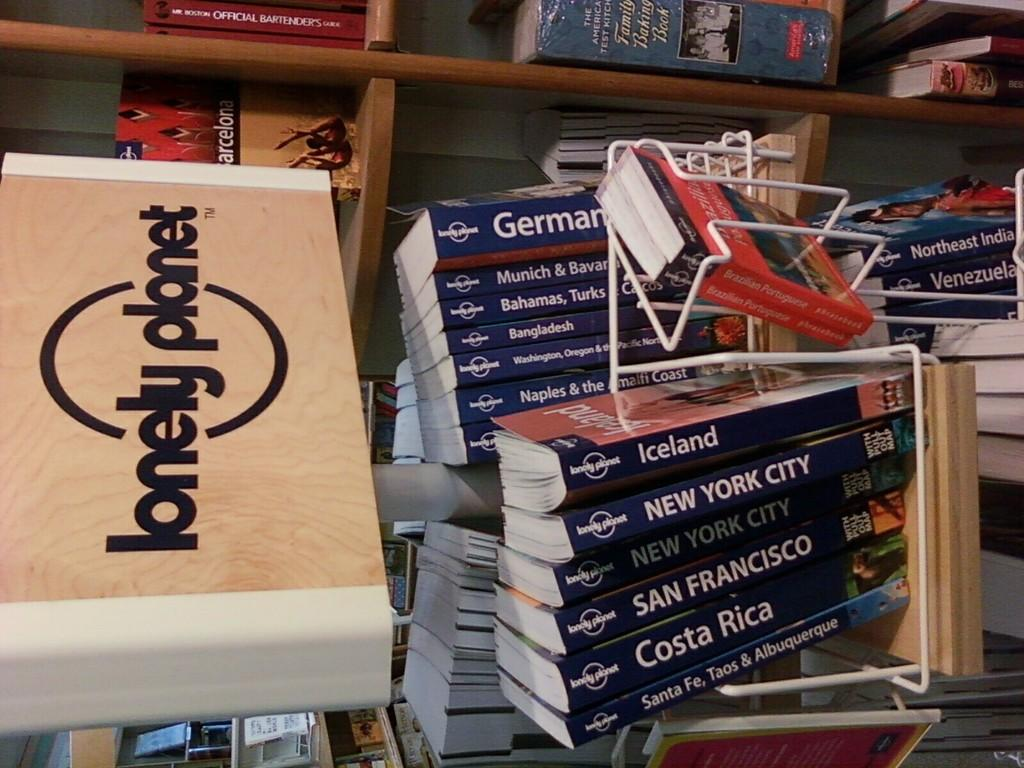Provide a one-sentence caption for the provided image. Shelves of new books of cities and a lonely planet brand. 